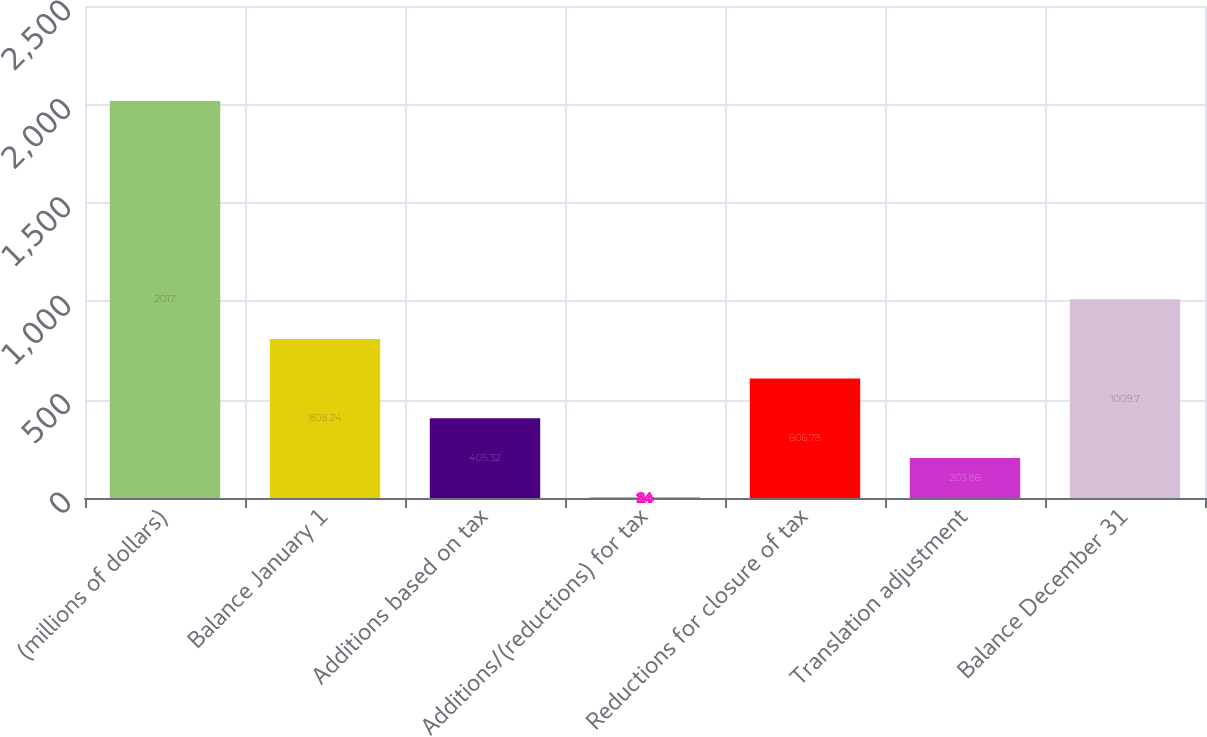Convert chart. <chart><loc_0><loc_0><loc_500><loc_500><bar_chart><fcel>(millions of dollars)<fcel>Balance January 1<fcel>Additions based on tax<fcel>Additions/(reductions) for tax<fcel>Reductions for closure of tax<fcel>Translation adjustment<fcel>Balance December 31<nl><fcel>2017<fcel>808.24<fcel>405.32<fcel>2.4<fcel>606.78<fcel>203.86<fcel>1009.7<nl></chart> 